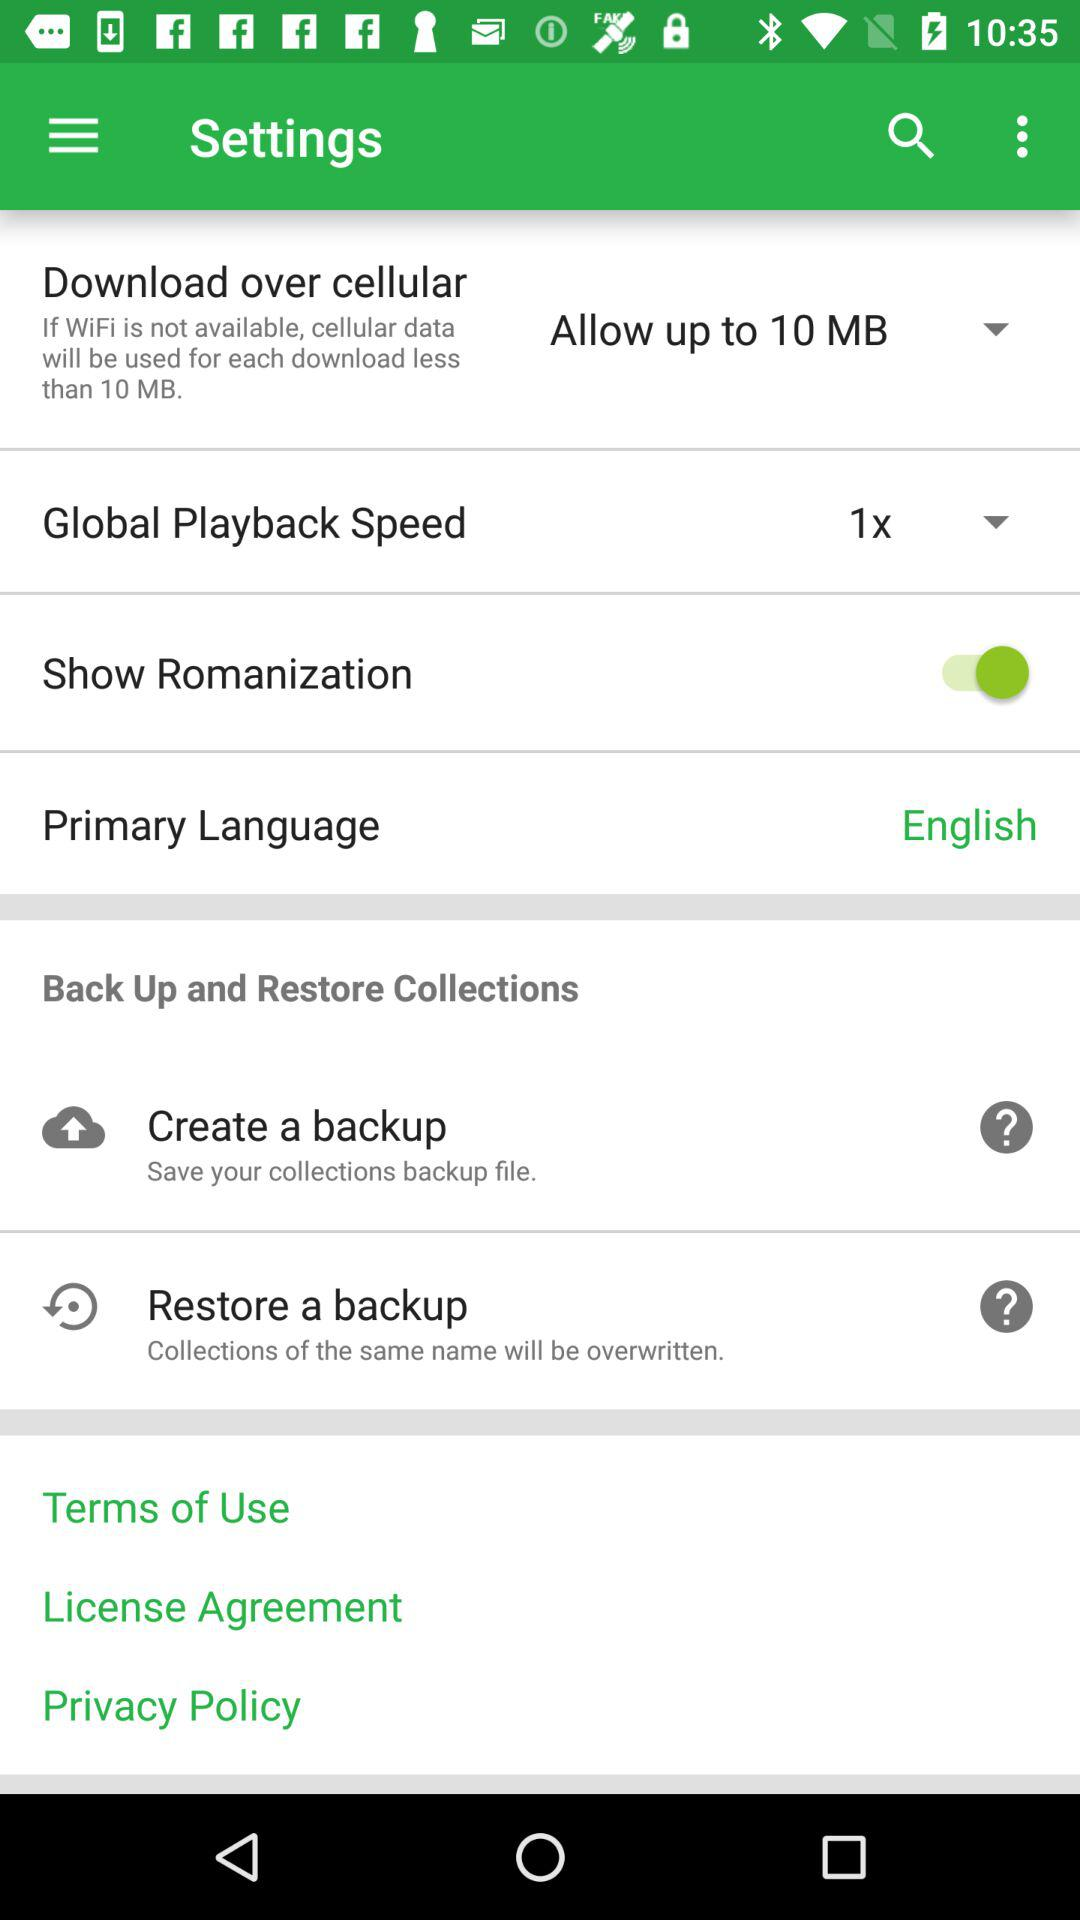What is the status of "Show Romanization"? The status is "on". 